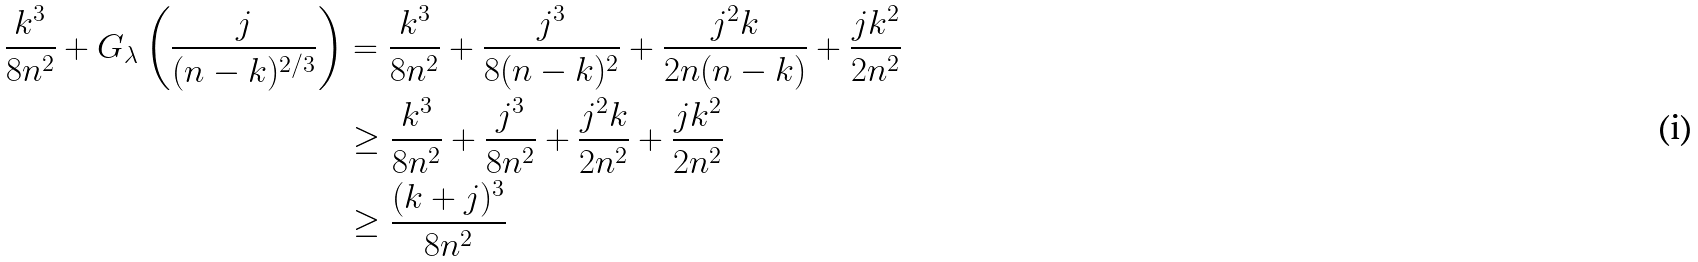Convert formula to latex. <formula><loc_0><loc_0><loc_500><loc_500>\frac { k ^ { 3 } } { 8 n ^ { 2 } } + G _ { \lambda } \left ( \frac { j } { ( n - k ) ^ { 2 / 3 } } \right ) & = \frac { k ^ { 3 } } { 8 n ^ { 2 } } + \frac { j ^ { 3 } } { 8 ( n - k ) ^ { 2 } } + \frac { j ^ { 2 } k } { 2 n ( n - k ) } + \frac { j k ^ { 2 } } { 2 n ^ { 2 } } \\ & \geq \frac { k ^ { 3 } } { 8 n ^ { 2 } } + \frac { j ^ { 3 } } { 8 n ^ { 2 } } + \frac { j ^ { 2 } k } { 2 n ^ { 2 } } + \frac { j k ^ { 2 } } { 2 n ^ { 2 } } \\ & \geq \frac { ( k + j ) ^ { 3 } } { 8 n ^ { 2 } }</formula> 